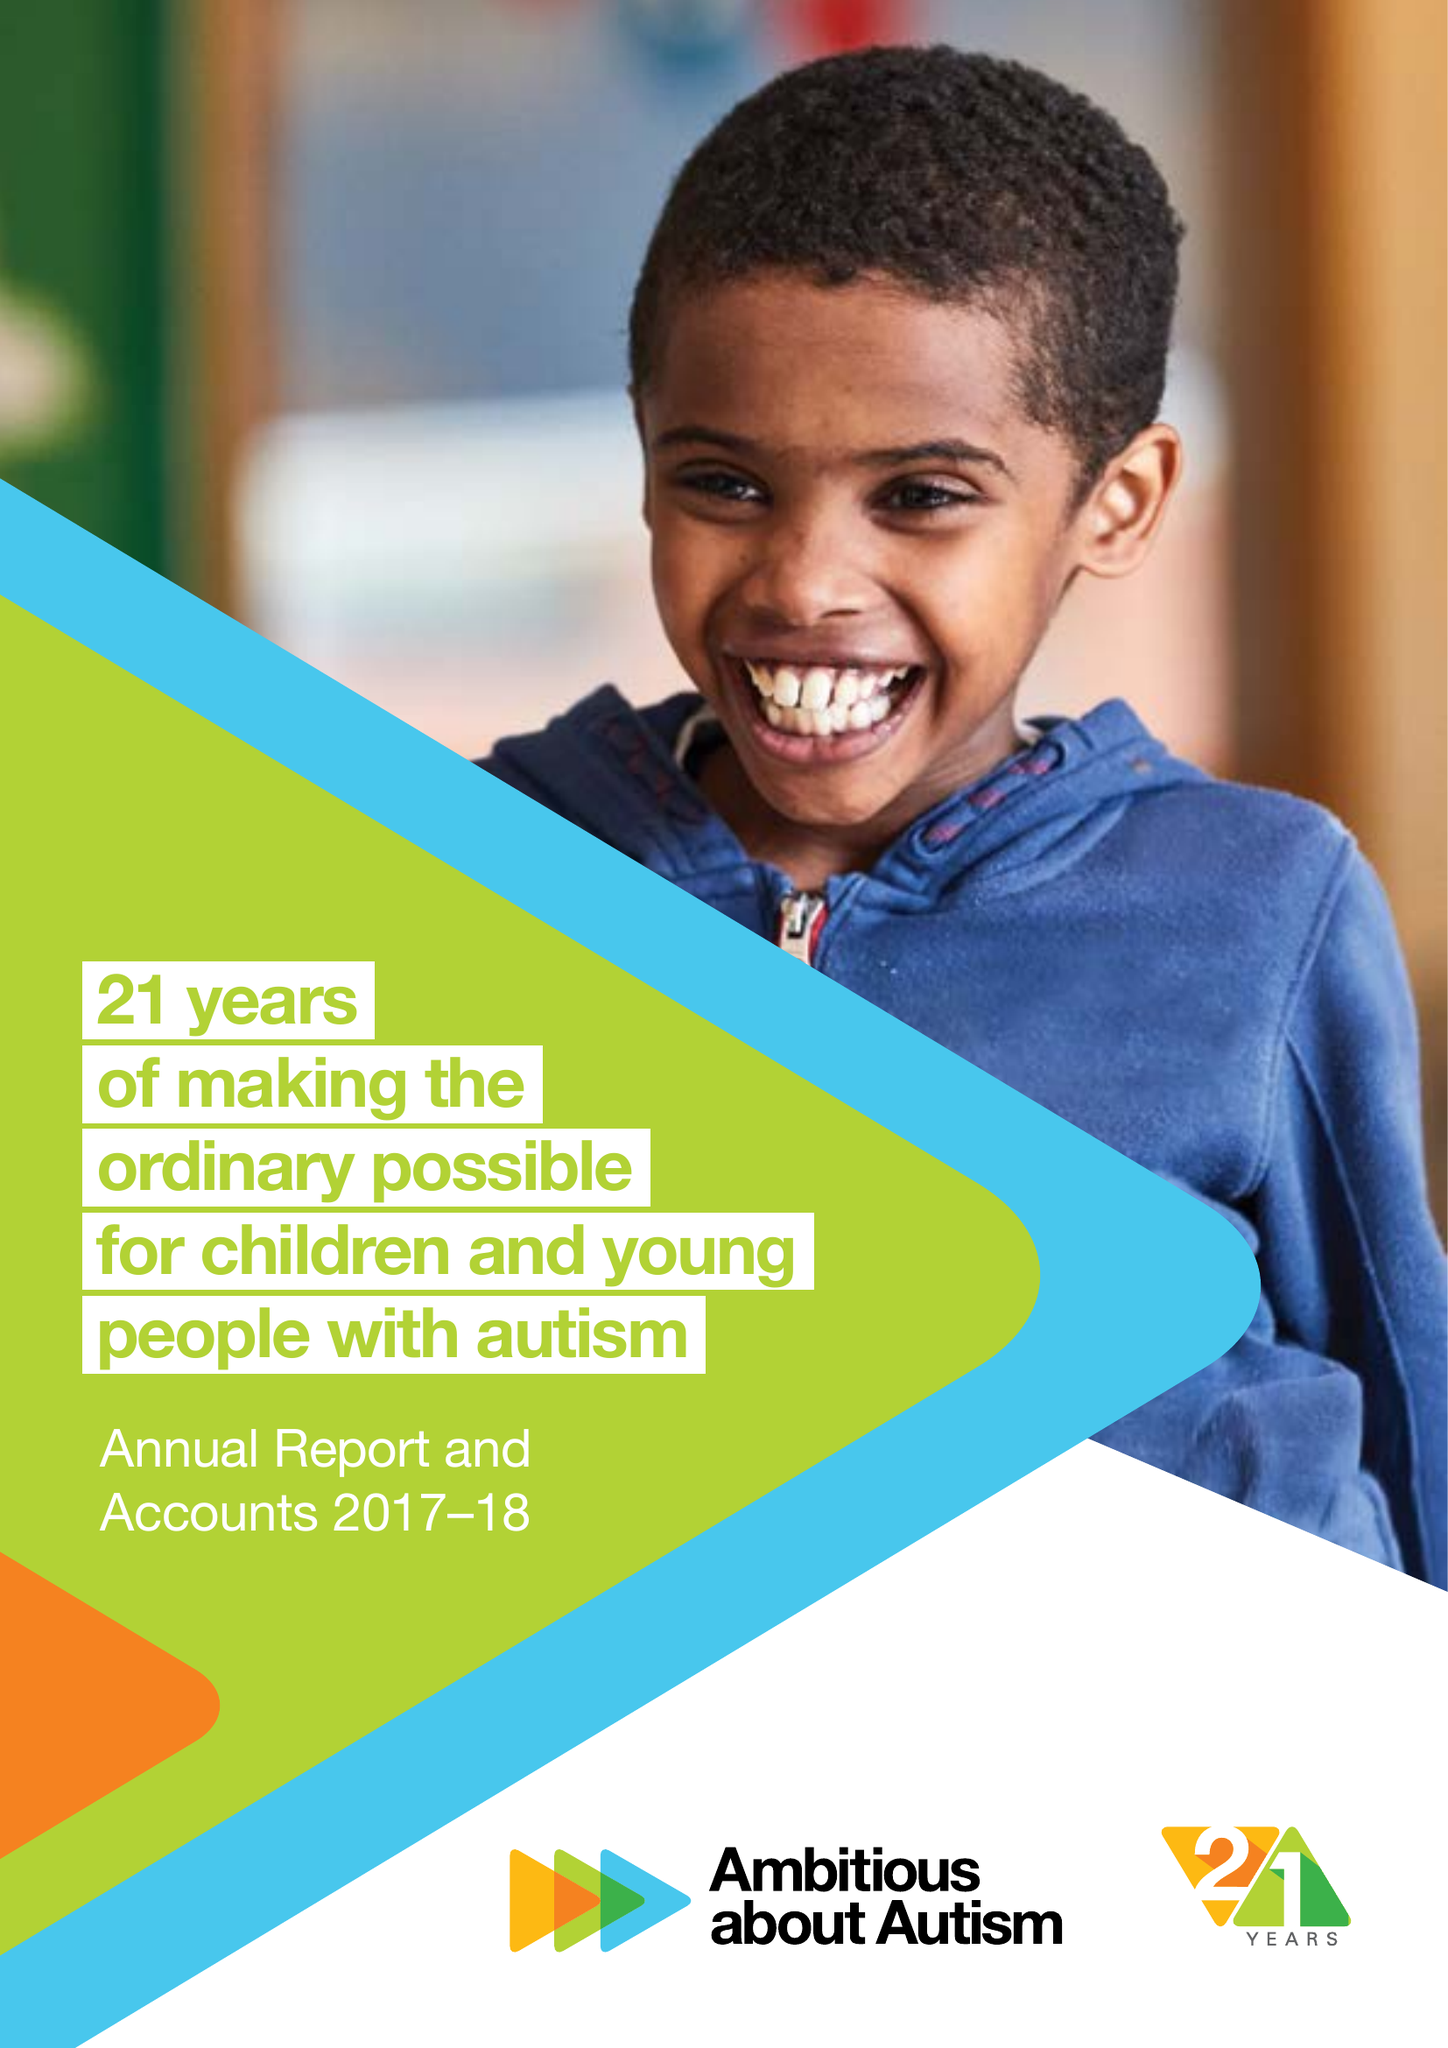What is the value for the spending_annually_in_british_pounds?
Answer the question using a single word or phrase. 15224000.00 